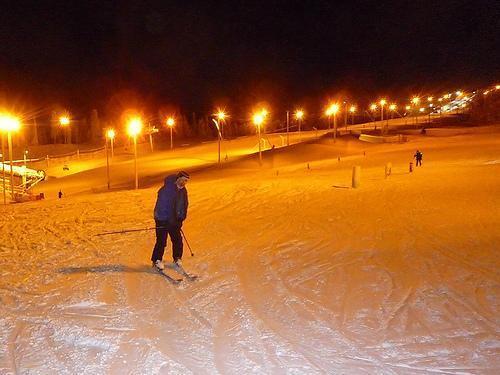How many people are shown?
Give a very brief answer. 2. 